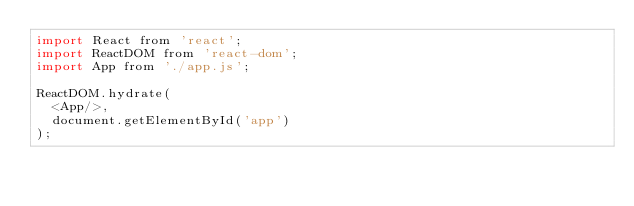<code> <loc_0><loc_0><loc_500><loc_500><_JavaScript_>import React from 'react';
import ReactDOM from 'react-dom';
import App from './app.js';

ReactDOM.hydrate(
  <App/>,
  document.getElementById('app')
);
</code> 